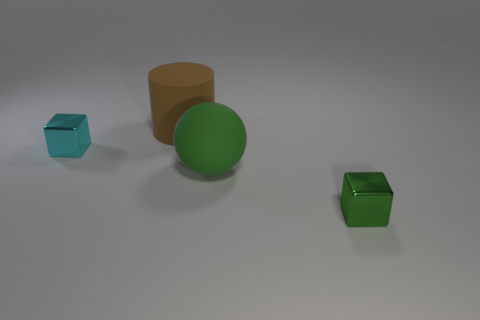There is a object that is in front of the tiny cyan metallic block and on the left side of the tiny green cube; how big is it?
Your answer should be very brief. Large. Do the tiny cyan object and the green metallic object have the same shape?
Your answer should be compact. Yes. The small cyan thing that is made of the same material as the green cube is what shape?
Make the answer very short. Cube. What number of big things are either cyan blocks or matte things?
Your response must be concise. 2. Is there a large brown cylinder that is in front of the big object behind the cyan metallic block?
Your answer should be compact. No. Are any brown rubber things visible?
Offer a terse response. Yes. What is the color of the metal block that is left of the large thing that is right of the big cylinder?
Make the answer very short. Cyan. There is a small cyan thing that is the same shape as the small green object; what material is it?
Make the answer very short. Metal. How many metal cubes have the same size as the brown matte object?
Make the answer very short. 0. What size is the other thing that is the same material as the cyan object?
Offer a terse response. Small. 